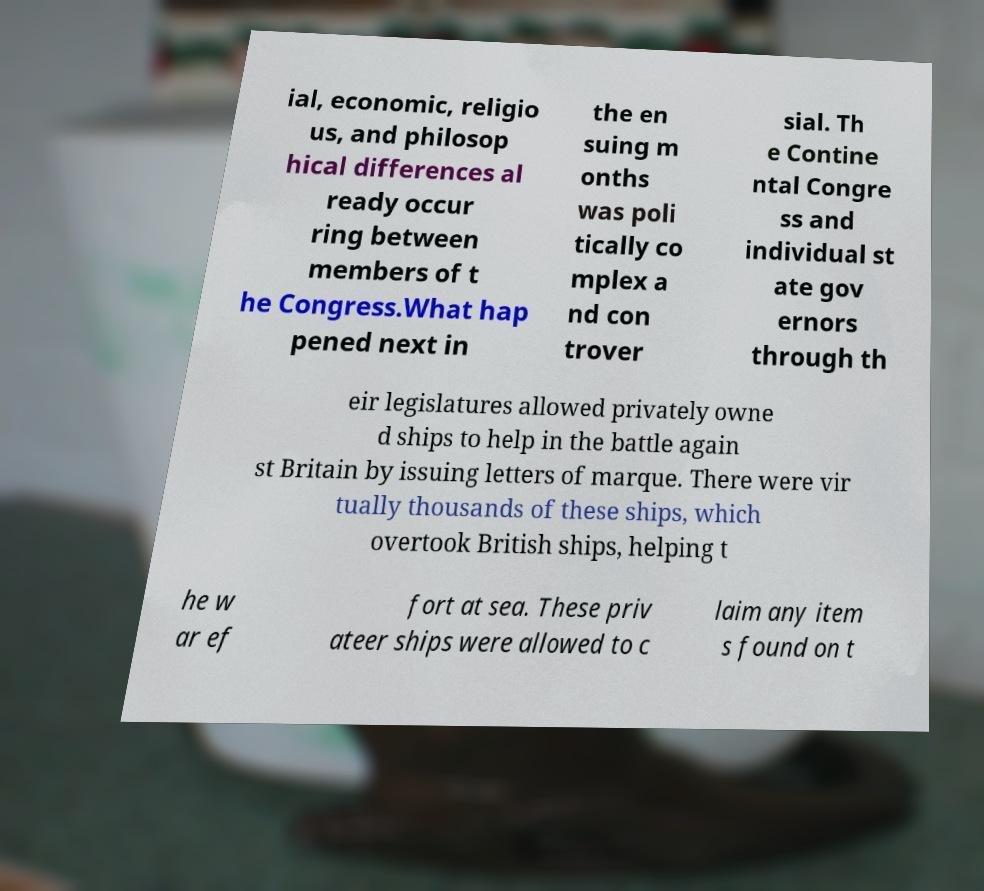Can you read and provide the text displayed in the image?This photo seems to have some interesting text. Can you extract and type it out for me? ial, economic, religio us, and philosop hical differences al ready occur ring between members of t he Congress.What hap pened next in the en suing m onths was poli tically co mplex a nd con trover sial. Th e Contine ntal Congre ss and individual st ate gov ernors through th eir legislatures allowed privately owne d ships to help in the battle again st Britain by issuing letters of marque. There were vir tually thousands of these ships, which overtook British ships, helping t he w ar ef fort at sea. These priv ateer ships were allowed to c laim any item s found on t 